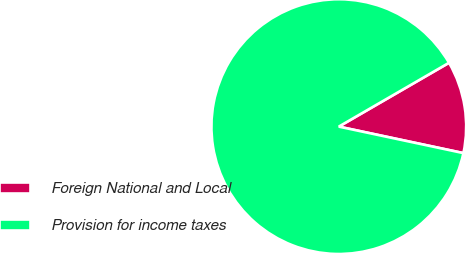<chart> <loc_0><loc_0><loc_500><loc_500><pie_chart><fcel>Foreign National and Local<fcel>Provision for income taxes<nl><fcel>11.69%<fcel>88.31%<nl></chart> 